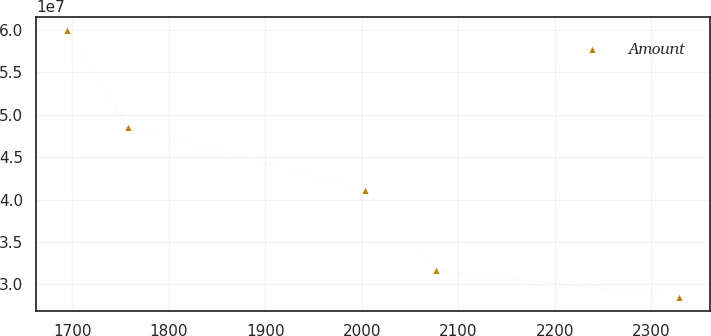Convert chart. <chart><loc_0><loc_0><loc_500><loc_500><line_chart><ecel><fcel>Amount<nl><fcel>1694.61<fcel>6.00068e+07<nl><fcel>1758.06<fcel>4.85941e+07<nl><fcel>2003.88<fcel>4.1135e+07<nl><fcel>2077.45<fcel>3.16466e+07<nl><fcel>2329.16<fcel>2.84954e+07<nl></chart> 